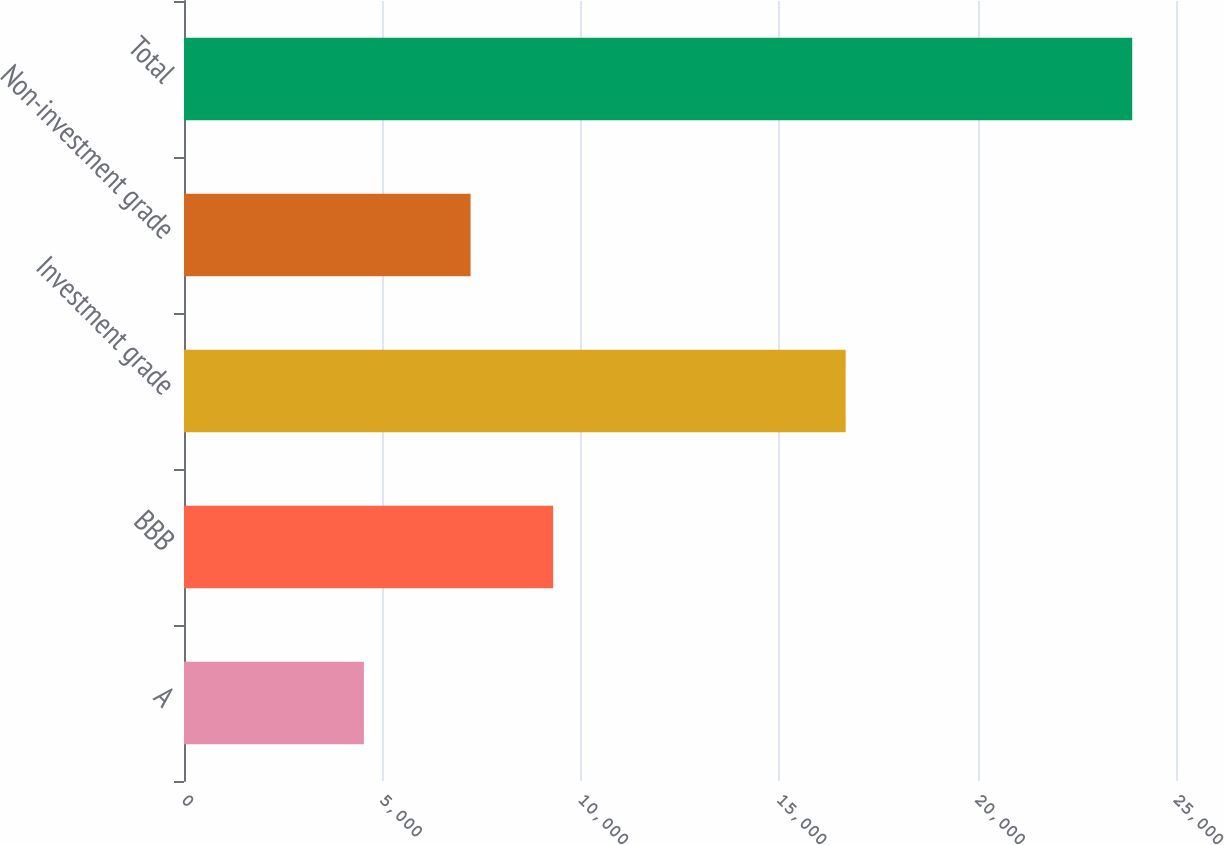<chart> <loc_0><loc_0><loc_500><loc_500><bar_chart><fcel>A<fcel>BBB<fcel>Investment grade<fcel>Non-investment grade<fcel>Total<nl><fcel>4534<fcel>9303<fcel>16675<fcel>7222<fcel>23897<nl></chart> 